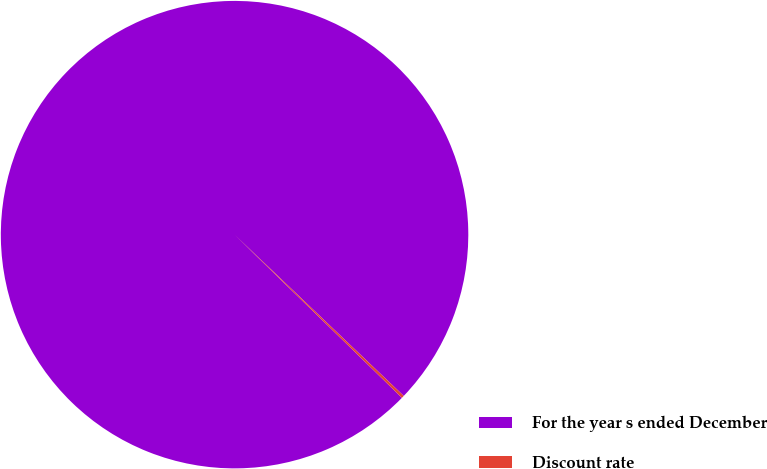<chart> <loc_0><loc_0><loc_500><loc_500><pie_chart><fcel>For the year s ended December<fcel>Discount rate<nl><fcel>99.82%<fcel>0.18%<nl></chart> 